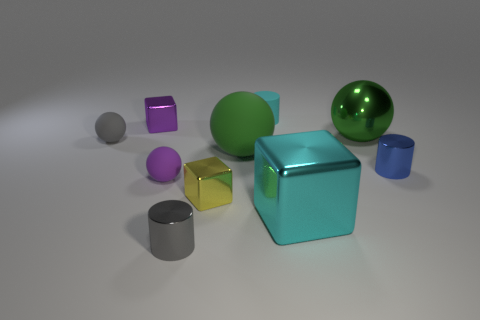Are there any small balls that have the same color as the rubber cylinder?
Offer a terse response. No. There is a big block that is the same color as the tiny rubber cylinder; what material is it?
Your answer should be very brief. Metal. What number of big blocks are the same color as the small rubber cylinder?
Provide a short and direct response. 1. What number of objects are small cubes behind the yellow shiny cube or big matte objects?
Provide a short and direct response. 2. What color is the big ball that is made of the same material as the tiny blue object?
Offer a terse response. Green. Is there a gray sphere of the same size as the green shiny object?
Give a very brief answer. No. How many things are either green matte objects that are behind the large block or cylinders left of the cyan rubber thing?
Provide a short and direct response. 2. What shape is the purple shiny thing that is the same size as the blue metal thing?
Your response must be concise. Cube. Is there another metallic thing of the same shape as the large cyan object?
Keep it short and to the point. Yes. Are there fewer tiny red shiny things than blue metal objects?
Your response must be concise. Yes. 